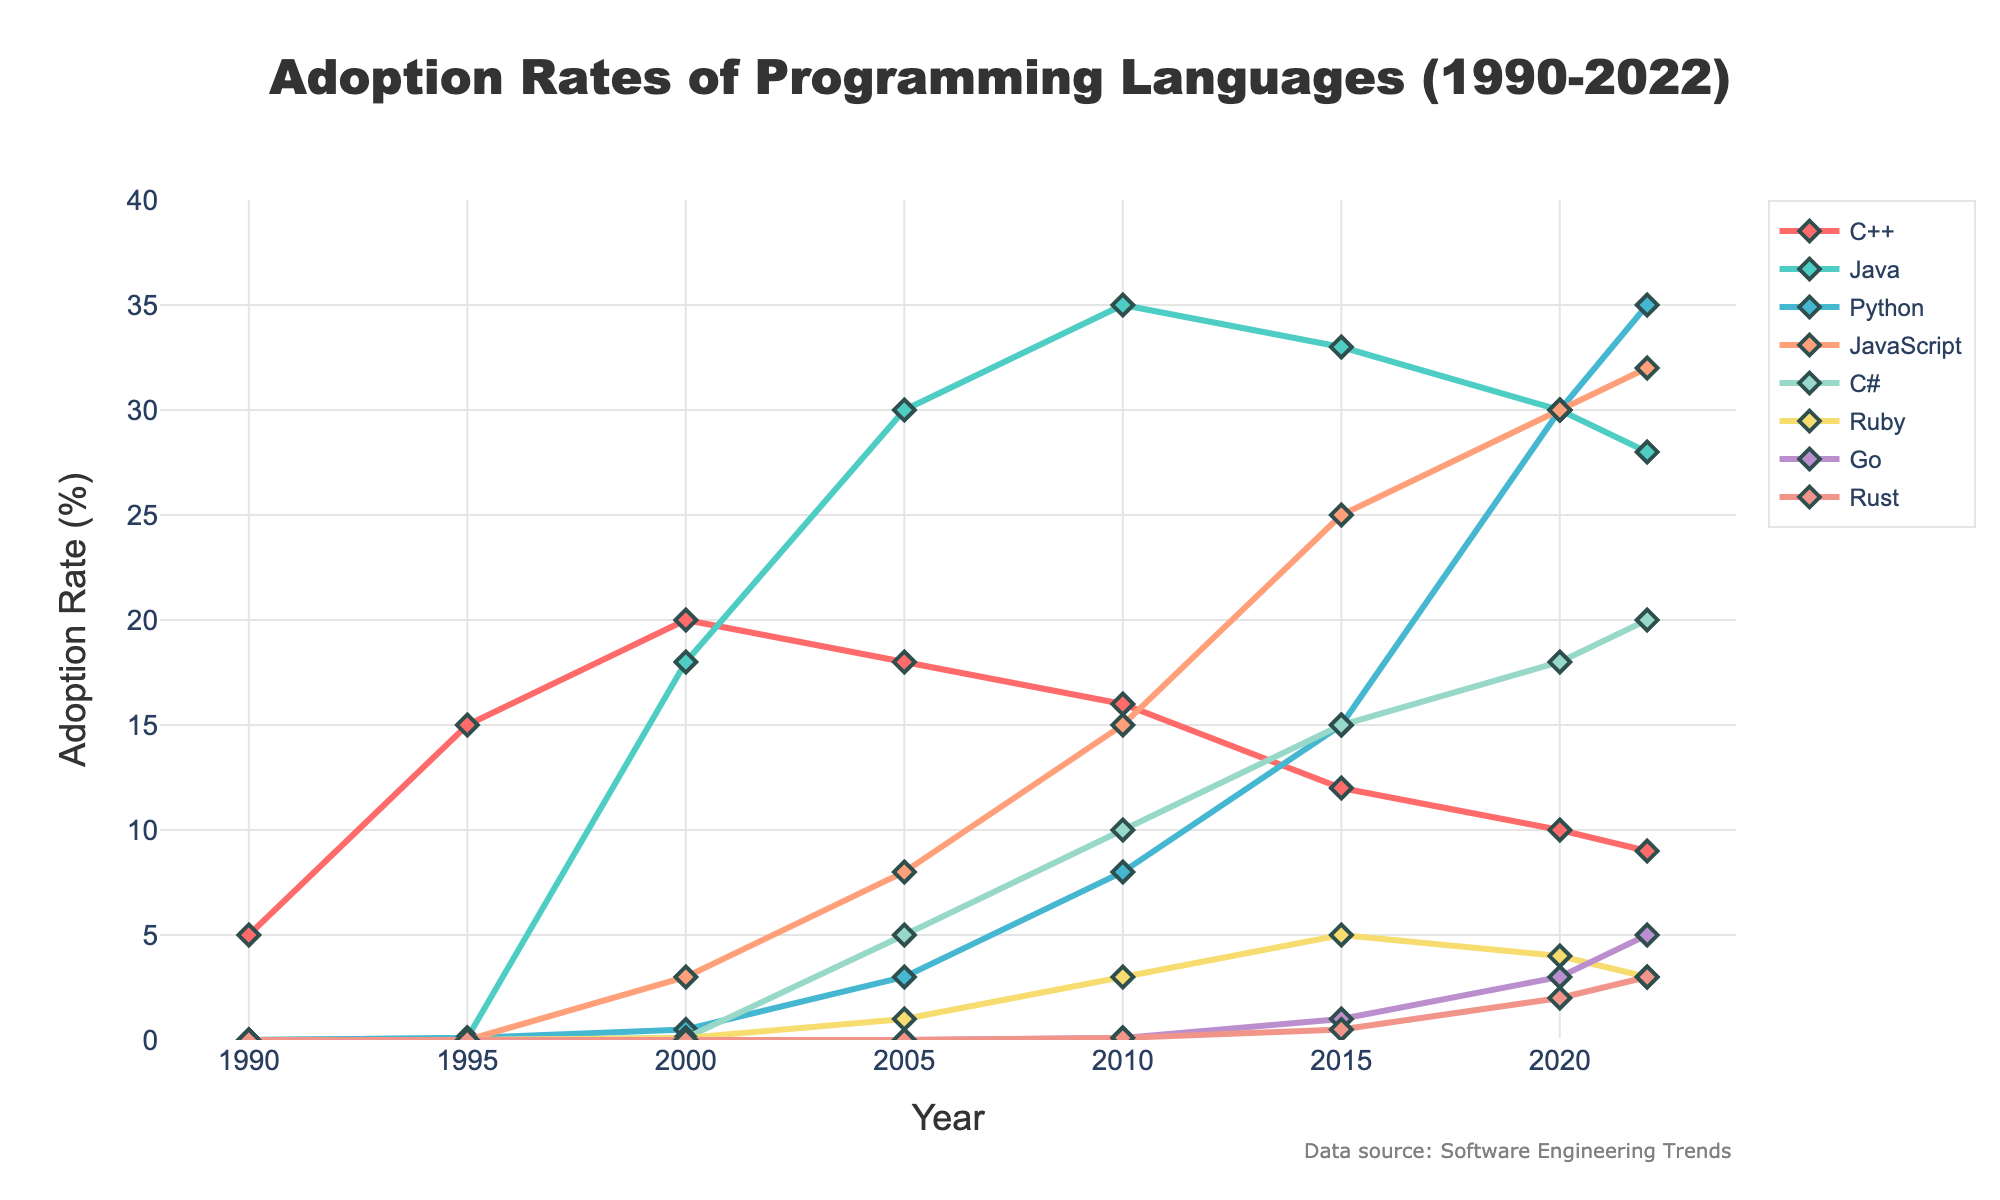Which programming language had the highest adoption rate in 2005? To find the highest adoption rate in 2005, look at the values for each programming language in the year 2005. Java has the highest adoption rate with a value of 30%
Answer: Java What is the difference in adoption rates between Python and JavaScript in 2010? To find the difference, look at the adoption rates for Python (8%) and JavaScript (15%) in the year 2010. The difference is 15% - 8% = 7%
Answer: 7% Which language shows a continuous increase in adoption rate from 1990 to 2022? From 1990 to 2022, Python shows a continuous increase in adoption rate in the figure. Starting from 0 in 1990 and reaching 35% in 2022 without any decrease.
Answer: Python What is the average adoption rate of C++ between 1990 and 2022? The adoption rates of C++ from 1990 to 2022 are 5, 15, 20, 18, 16, 12, 10, and 9. Adding these up gives 105, and there are 8 data points, so the average is 105/8 = 13.125%
Answer: 13.125% How much did the adoption rate of Ruby change between 2005 and 2022? In 2005, the adoption rate of Ruby was 1%, and in 2022 it was 3%. The change is 3% - 1% = 2%
Answer: 2% Which language had a higher adoption rate in 2020, JavaScript or C#? Looking at the year 2020, the adoption rate for JavaScript is 30%, while C# is 18%. JavaScript has the higher adoption rate.
Answer: JavaScript What is the total adoption rate of all languages combined in 1995? The adoption rates for all languages in 1995 are 15 (C++), 0.1 (Java), 0.1 (Python), 0 (JavaScript), 0 (C#), 0 (Ruby), 0 (Go), and 0 (Rust). Summing these gives 15.2%
Answer: 15.2% Which language had the largest increase in adoption rate between 2000 and 2010? Between 2000 and 2010, Python had the largest increase in adoption rate, from 0.5% to 8%, which is an increase of 7.5%.
Answer: Python What trend do you observe for Java's adoption rate from 2000 to 2022? Java's adoption rate increased from 18% in 2000 to 35% in 2010, then gradually decreased to 28% by 2022.
Answer: Increased then decreased Compare the adoption rates of Go and Rust in 2022. Which one is higher? In 2022, the adoption rate for Go is 5%, whereas for Rust it is 3%. Go has the higher adoption rate.
Answer: Go 